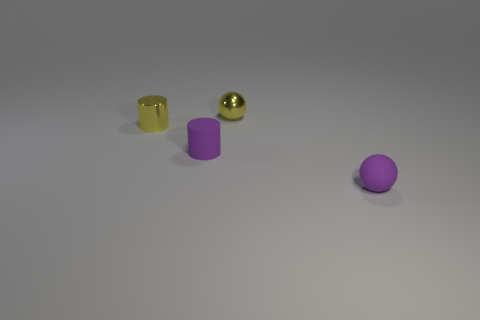Are there any yellow things?
Provide a succinct answer. Yes. There is a object that is the same material as the tiny purple cylinder; what color is it?
Your answer should be very brief. Purple. What is the color of the small ball that is in front of the cylinder behind the small purple thing behind the purple matte sphere?
Make the answer very short. Purple. There is a yellow shiny cylinder; is it the same size as the purple thing behind the purple matte sphere?
Your response must be concise. Yes. How many things are tiny matte things to the left of the tiny matte ball or metal things that are to the right of the small yellow metal cylinder?
Your response must be concise. 2. What is the shape of the purple thing that is the same size as the purple rubber ball?
Keep it short and to the point. Cylinder. The thing in front of the small purple matte cylinder to the left of the sphere in front of the small purple cylinder is what shape?
Your response must be concise. Sphere. Are there an equal number of small rubber objects that are behind the small yellow metallic cylinder and small purple balls?
Provide a short and direct response. No. Is the yellow shiny cylinder the same size as the purple sphere?
Your answer should be very brief. Yes. What number of metal objects are tiny cylinders or small yellow objects?
Your answer should be compact. 2. 